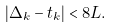Convert formula to latex. <formula><loc_0><loc_0><loc_500><loc_500>| \Delta _ { k } - t _ { k } | < 8 \L L .</formula> 